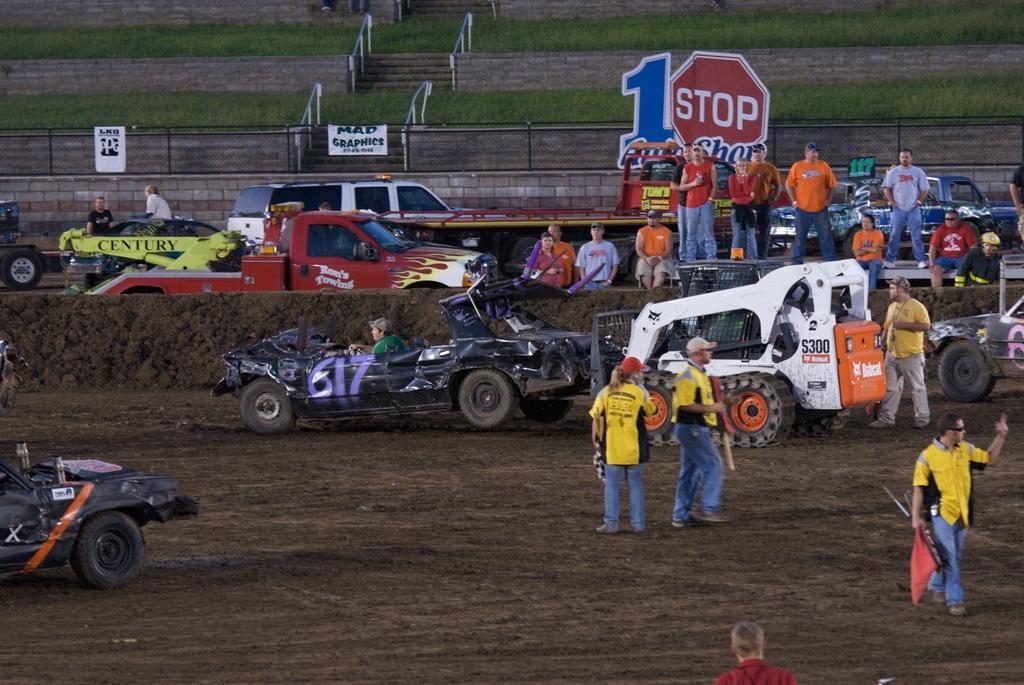Describe this image in one or two sentences. In this image, I can see few people standing and few people sitting. These are the trucks and cars, which are moving. This looks like a hoarding of a signboard. This is a fence. These are the stairs with the staircase holder. This is the grass. I can see the wall. 